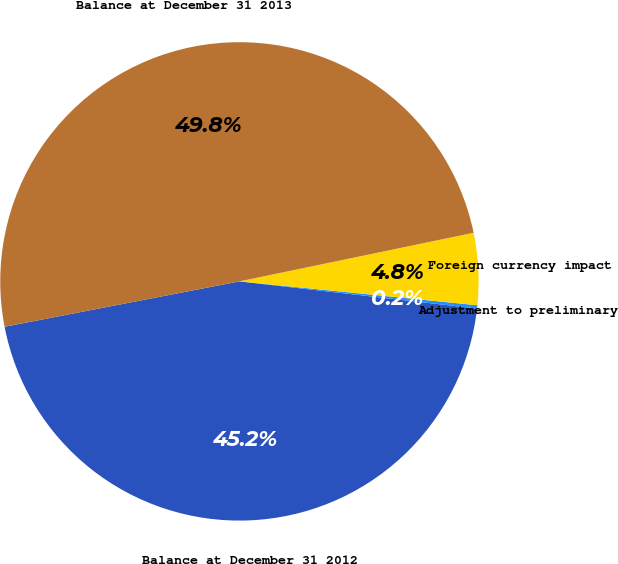Convert chart. <chart><loc_0><loc_0><loc_500><loc_500><pie_chart><fcel>Balance at December 31 2012<fcel>Adjustment to preliminary<fcel>Foreign currency impact<fcel>Balance at December 31 2013<nl><fcel>45.15%<fcel>0.22%<fcel>4.85%<fcel>49.78%<nl></chart> 